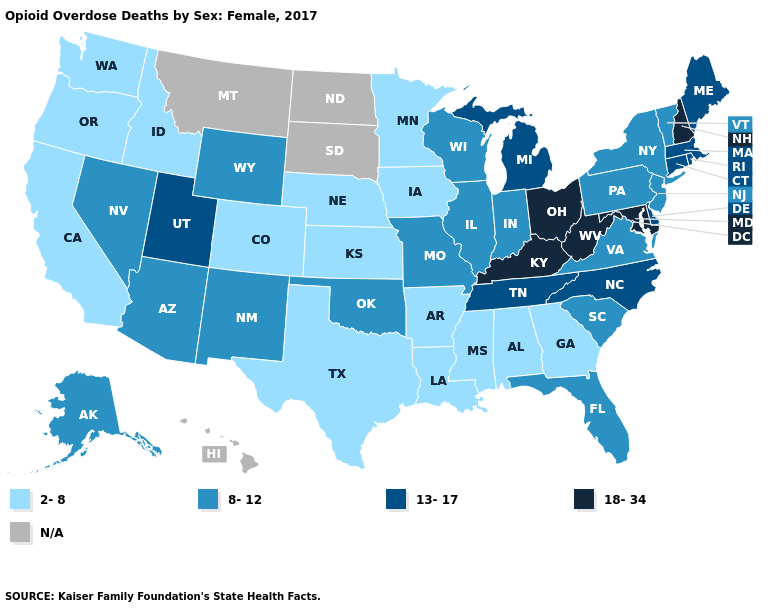What is the lowest value in the USA?
Give a very brief answer. 2-8. Name the states that have a value in the range 8-12?
Give a very brief answer. Alaska, Arizona, Florida, Illinois, Indiana, Missouri, Nevada, New Jersey, New Mexico, New York, Oklahoma, Pennsylvania, South Carolina, Vermont, Virginia, Wisconsin, Wyoming. What is the lowest value in the USA?
Short answer required. 2-8. What is the value of Maine?
Be succinct. 13-17. What is the highest value in states that border Nebraska?
Be succinct. 8-12. Among the states that border Michigan , does Ohio have the lowest value?
Concise answer only. No. Among the states that border Pennsylvania , which have the lowest value?
Short answer required. New Jersey, New York. Which states have the lowest value in the South?
Short answer required. Alabama, Arkansas, Georgia, Louisiana, Mississippi, Texas. What is the value of Montana?
Quick response, please. N/A. What is the highest value in the USA?
Quick response, please. 18-34. Is the legend a continuous bar?
Be succinct. No. Which states have the lowest value in the USA?
Keep it brief. Alabama, Arkansas, California, Colorado, Georgia, Idaho, Iowa, Kansas, Louisiana, Minnesota, Mississippi, Nebraska, Oregon, Texas, Washington. Name the states that have a value in the range 13-17?
Be succinct. Connecticut, Delaware, Maine, Massachusetts, Michigan, North Carolina, Rhode Island, Tennessee, Utah. What is the value of Mississippi?
Answer briefly. 2-8. 